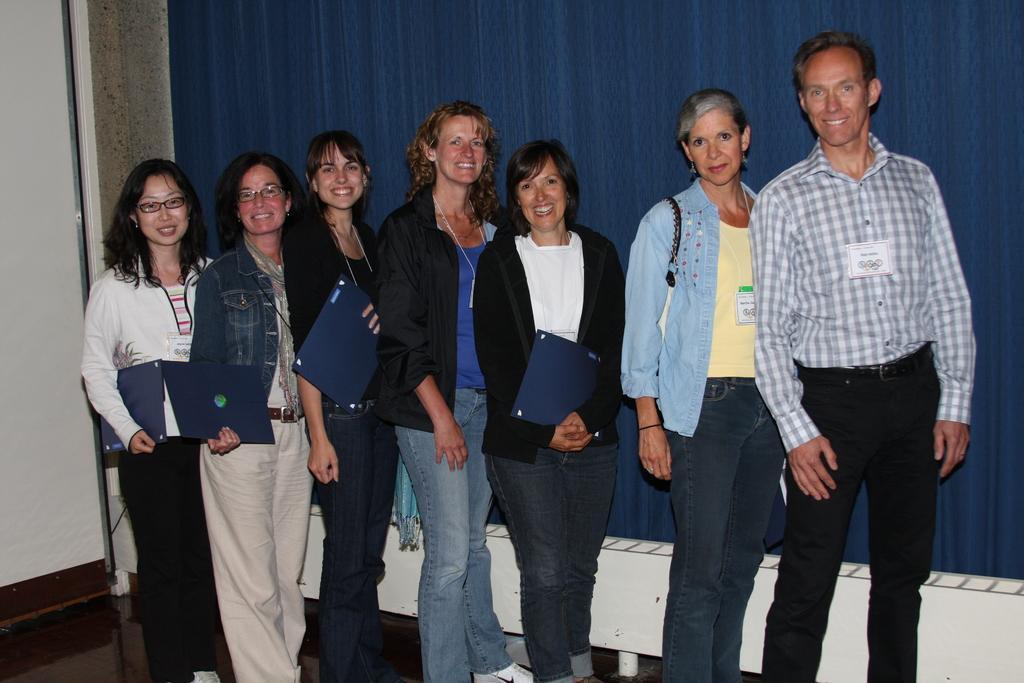How would you summarize this image in a sentence or two? In this image I can see there are few persons standing on the floor and there are smiling and background is in color blue. 